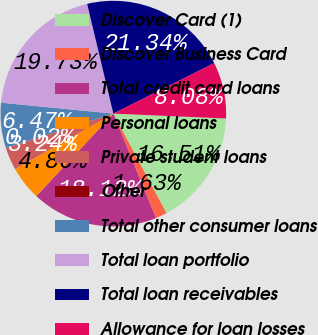<chart> <loc_0><loc_0><loc_500><loc_500><pie_chart><fcel>Discover Card (1)<fcel>Discover Business Card<fcel>Total credit card loans<fcel>Personal loans<fcel>Private student loans<fcel>Other<fcel>Total other consumer loans<fcel>Total loan portfolio<fcel>Total loan receivables<fcel>Allowance for loan losses<nl><fcel>16.51%<fcel>1.63%<fcel>18.12%<fcel>4.86%<fcel>3.24%<fcel>0.02%<fcel>6.47%<fcel>19.73%<fcel>21.34%<fcel>8.08%<nl></chart> 